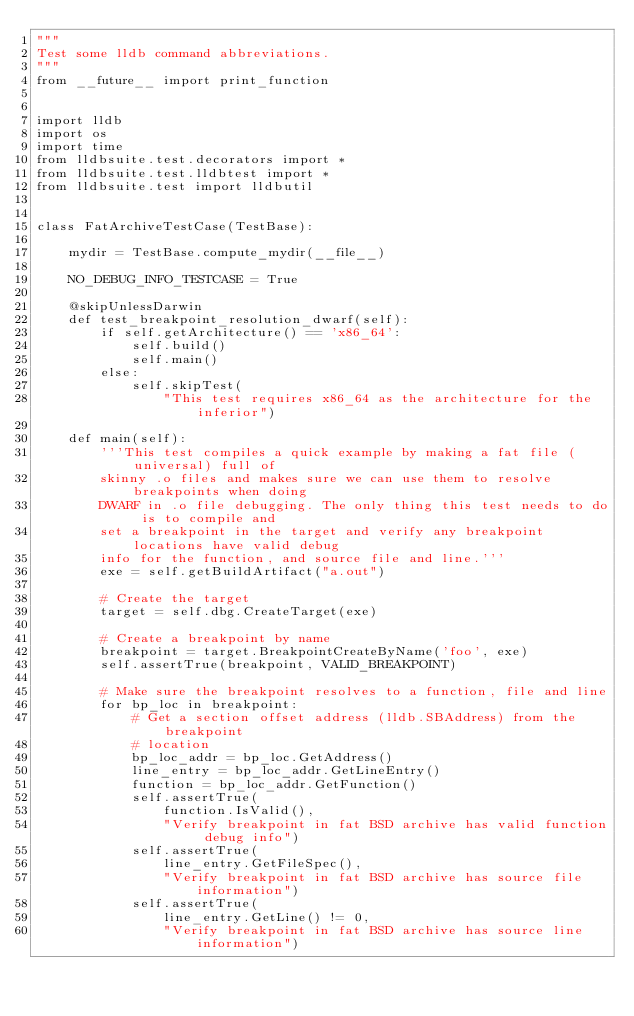<code> <loc_0><loc_0><loc_500><loc_500><_Python_>"""
Test some lldb command abbreviations.
"""
from __future__ import print_function


import lldb
import os
import time
from lldbsuite.test.decorators import *
from lldbsuite.test.lldbtest import *
from lldbsuite.test import lldbutil


class FatArchiveTestCase(TestBase):

    mydir = TestBase.compute_mydir(__file__)

    NO_DEBUG_INFO_TESTCASE = True

    @skipUnlessDarwin
    def test_breakpoint_resolution_dwarf(self):
        if self.getArchitecture() == 'x86_64':
            self.build()
            self.main()
        else:
            self.skipTest(
                "This test requires x86_64 as the architecture for the inferior")

    def main(self):
        '''This test compiles a quick example by making a fat file (universal) full of
        skinny .o files and makes sure we can use them to resolve breakpoints when doing
        DWARF in .o file debugging. The only thing this test needs to do is to compile and
        set a breakpoint in the target and verify any breakpoint locations have valid debug
        info for the function, and source file and line.'''
        exe = self.getBuildArtifact("a.out")

        # Create the target
        target = self.dbg.CreateTarget(exe)

        # Create a breakpoint by name
        breakpoint = target.BreakpointCreateByName('foo', exe)
        self.assertTrue(breakpoint, VALID_BREAKPOINT)

        # Make sure the breakpoint resolves to a function, file and line
        for bp_loc in breakpoint:
            # Get a section offset address (lldb.SBAddress) from the breakpoint
            # location
            bp_loc_addr = bp_loc.GetAddress()
            line_entry = bp_loc_addr.GetLineEntry()
            function = bp_loc_addr.GetFunction()
            self.assertTrue(
                function.IsValid(),
                "Verify breakpoint in fat BSD archive has valid function debug info")
            self.assertTrue(
                line_entry.GetFileSpec(),
                "Verify breakpoint in fat BSD archive has source file information")
            self.assertTrue(
                line_entry.GetLine() != 0,
                "Verify breakpoint in fat BSD archive has source line information")
</code> 